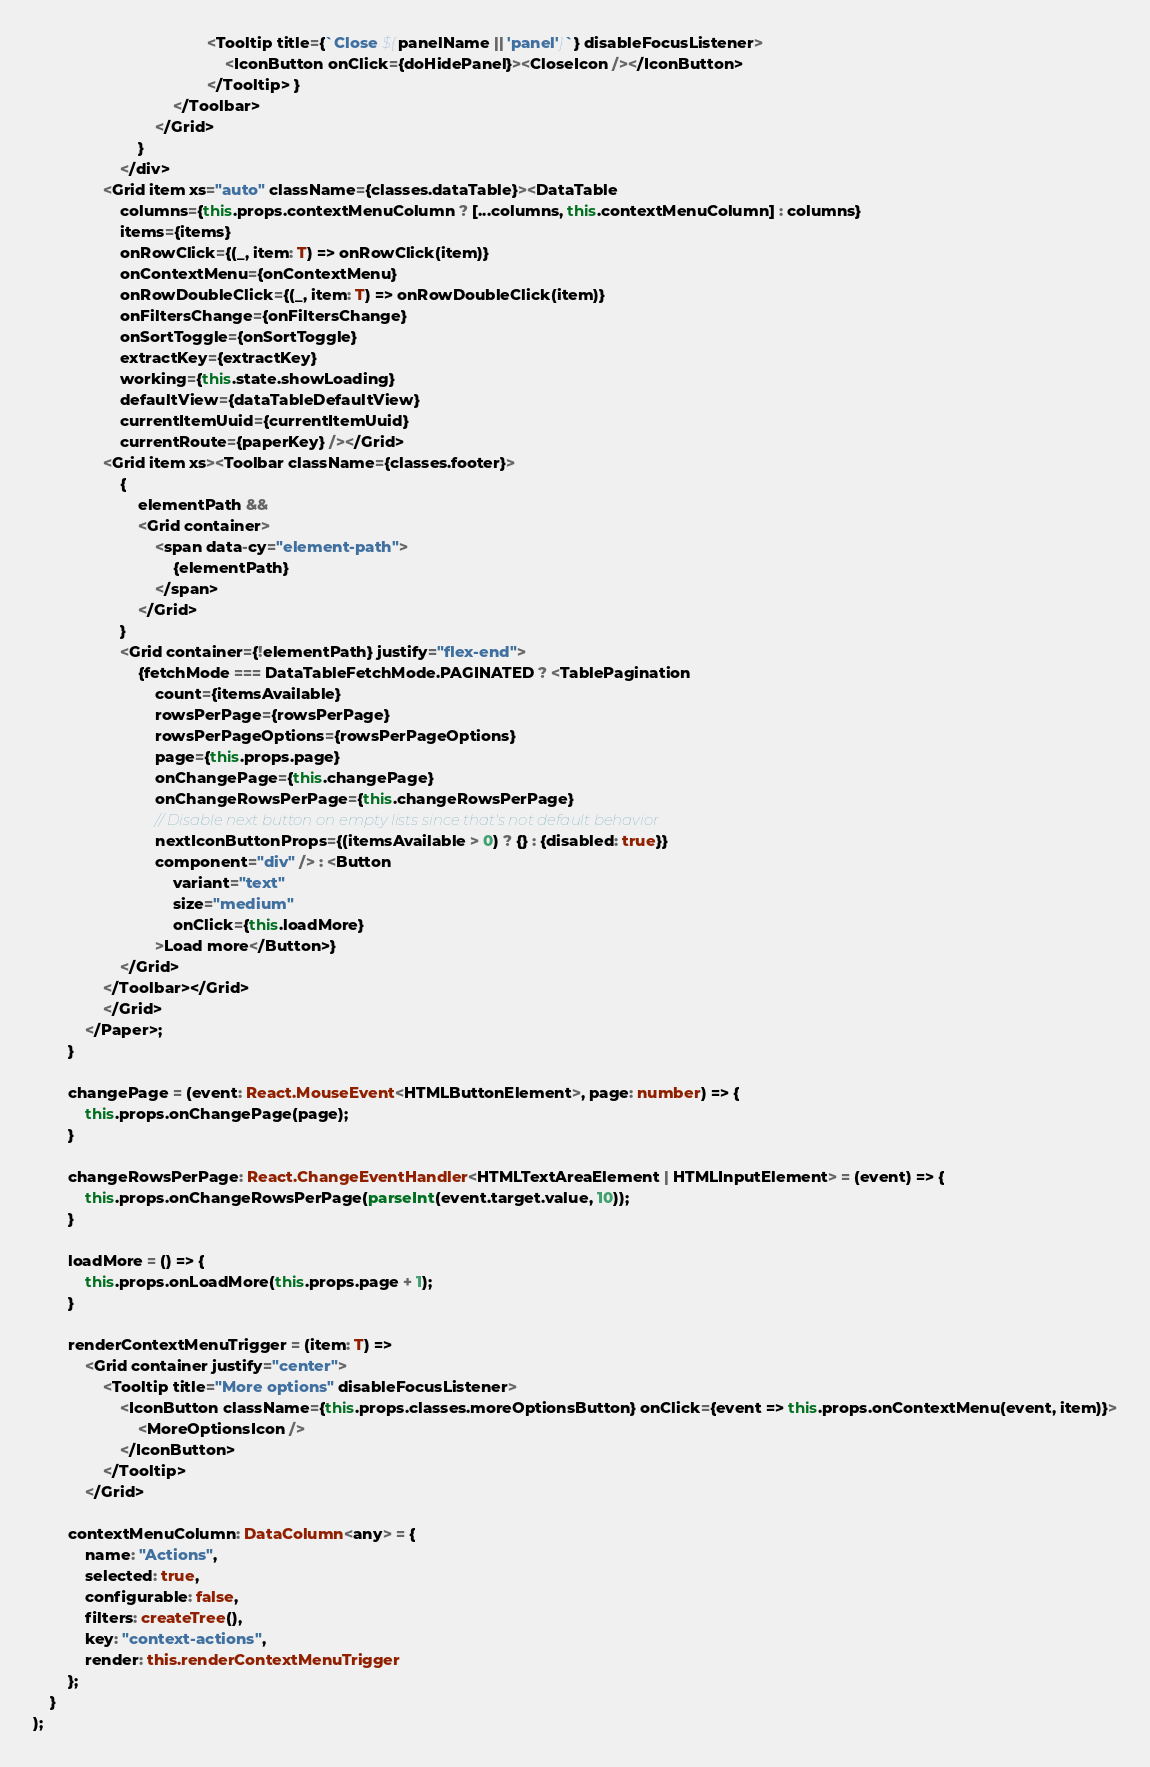<code> <loc_0><loc_0><loc_500><loc_500><_TypeScript_>                                        <Tooltip title={`Close ${panelName || 'panel'}`} disableFocusListener>
                                            <IconButton onClick={doHidePanel}><CloseIcon /></IconButton>
                                        </Tooltip> }
                                </Toolbar>
                            </Grid>
                        }
                    </div>
                <Grid item xs="auto" className={classes.dataTable}><DataTable
                    columns={this.props.contextMenuColumn ? [...columns, this.contextMenuColumn] : columns}
                    items={items}
                    onRowClick={(_, item: T) => onRowClick(item)}
                    onContextMenu={onContextMenu}
                    onRowDoubleClick={(_, item: T) => onRowDoubleClick(item)}
                    onFiltersChange={onFiltersChange}
                    onSortToggle={onSortToggle}
                    extractKey={extractKey}
                    working={this.state.showLoading}
                    defaultView={dataTableDefaultView}
                    currentItemUuid={currentItemUuid}
                    currentRoute={paperKey} /></Grid>
                <Grid item xs><Toolbar className={classes.footer}>
                    {
                        elementPath &&
                        <Grid container>
                            <span data-cy="element-path">
                                {elementPath}
                            </span>
                        </Grid>
                    }
                    <Grid container={!elementPath} justify="flex-end">
                        {fetchMode === DataTableFetchMode.PAGINATED ? <TablePagination
                            count={itemsAvailable}
                            rowsPerPage={rowsPerPage}
                            rowsPerPageOptions={rowsPerPageOptions}
                            page={this.props.page}
                            onChangePage={this.changePage}
                            onChangeRowsPerPage={this.changeRowsPerPage}
                            // Disable next button on empty lists since that's not default behavior
                            nextIconButtonProps={(itemsAvailable > 0) ? {} : {disabled: true}}
                            component="div" /> : <Button
                                variant="text"
                                size="medium"
                                onClick={this.loadMore}
                            >Load more</Button>}
                    </Grid>
                </Toolbar></Grid>
                </Grid>
            </Paper>;
        }

        changePage = (event: React.MouseEvent<HTMLButtonElement>, page: number) => {
            this.props.onChangePage(page);
        }

        changeRowsPerPage: React.ChangeEventHandler<HTMLTextAreaElement | HTMLInputElement> = (event) => {
            this.props.onChangeRowsPerPage(parseInt(event.target.value, 10));
        }

        loadMore = () => {
            this.props.onLoadMore(this.props.page + 1);
        }

        renderContextMenuTrigger = (item: T) =>
            <Grid container justify="center">
                <Tooltip title="More options" disableFocusListener>
                    <IconButton className={this.props.classes.moreOptionsButton} onClick={event => this.props.onContextMenu(event, item)}>
                        <MoreOptionsIcon />
                    </IconButton>
                </Tooltip>
            </Grid>

        contextMenuColumn: DataColumn<any> = {
            name: "Actions",
            selected: true,
            configurable: false,
            filters: createTree(),
            key: "context-actions",
            render: this.renderContextMenuTrigger
        };
    }
);
</code> 